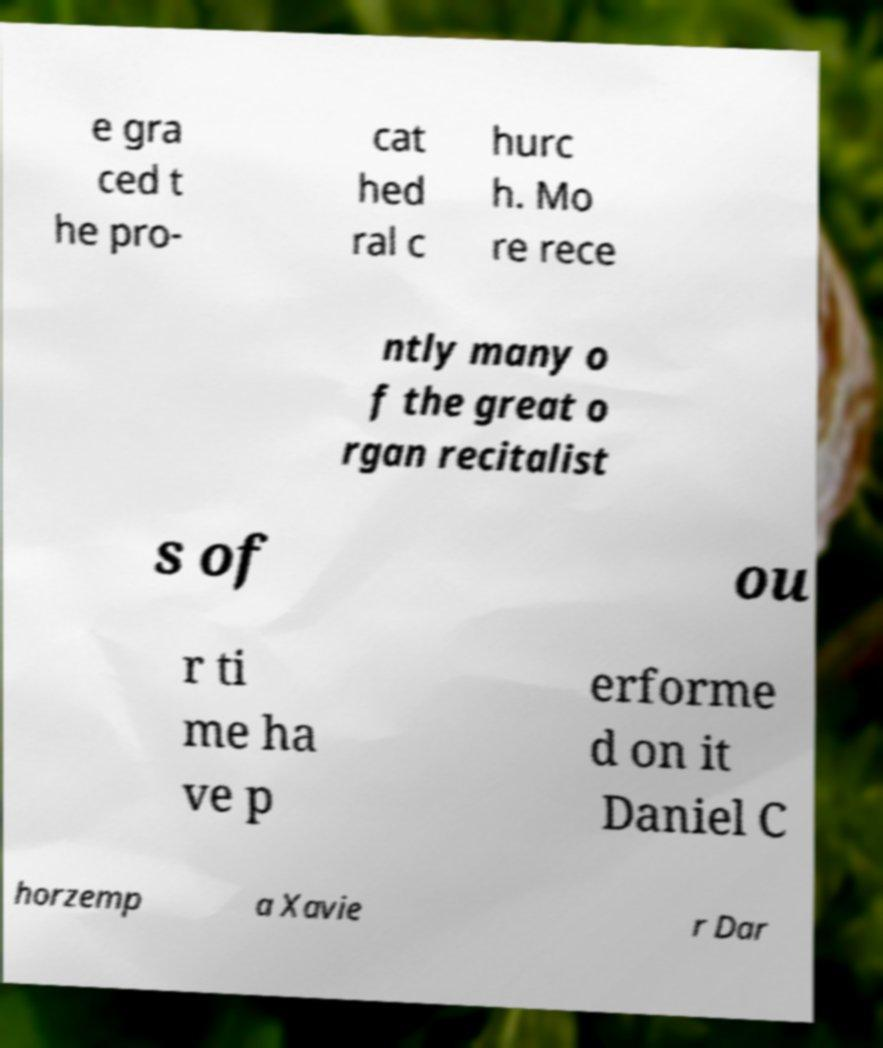For documentation purposes, I need the text within this image transcribed. Could you provide that? e gra ced t he pro- cat hed ral c hurc h. Mo re rece ntly many o f the great o rgan recitalist s of ou r ti me ha ve p erforme d on it Daniel C horzemp a Xavie r Dar 